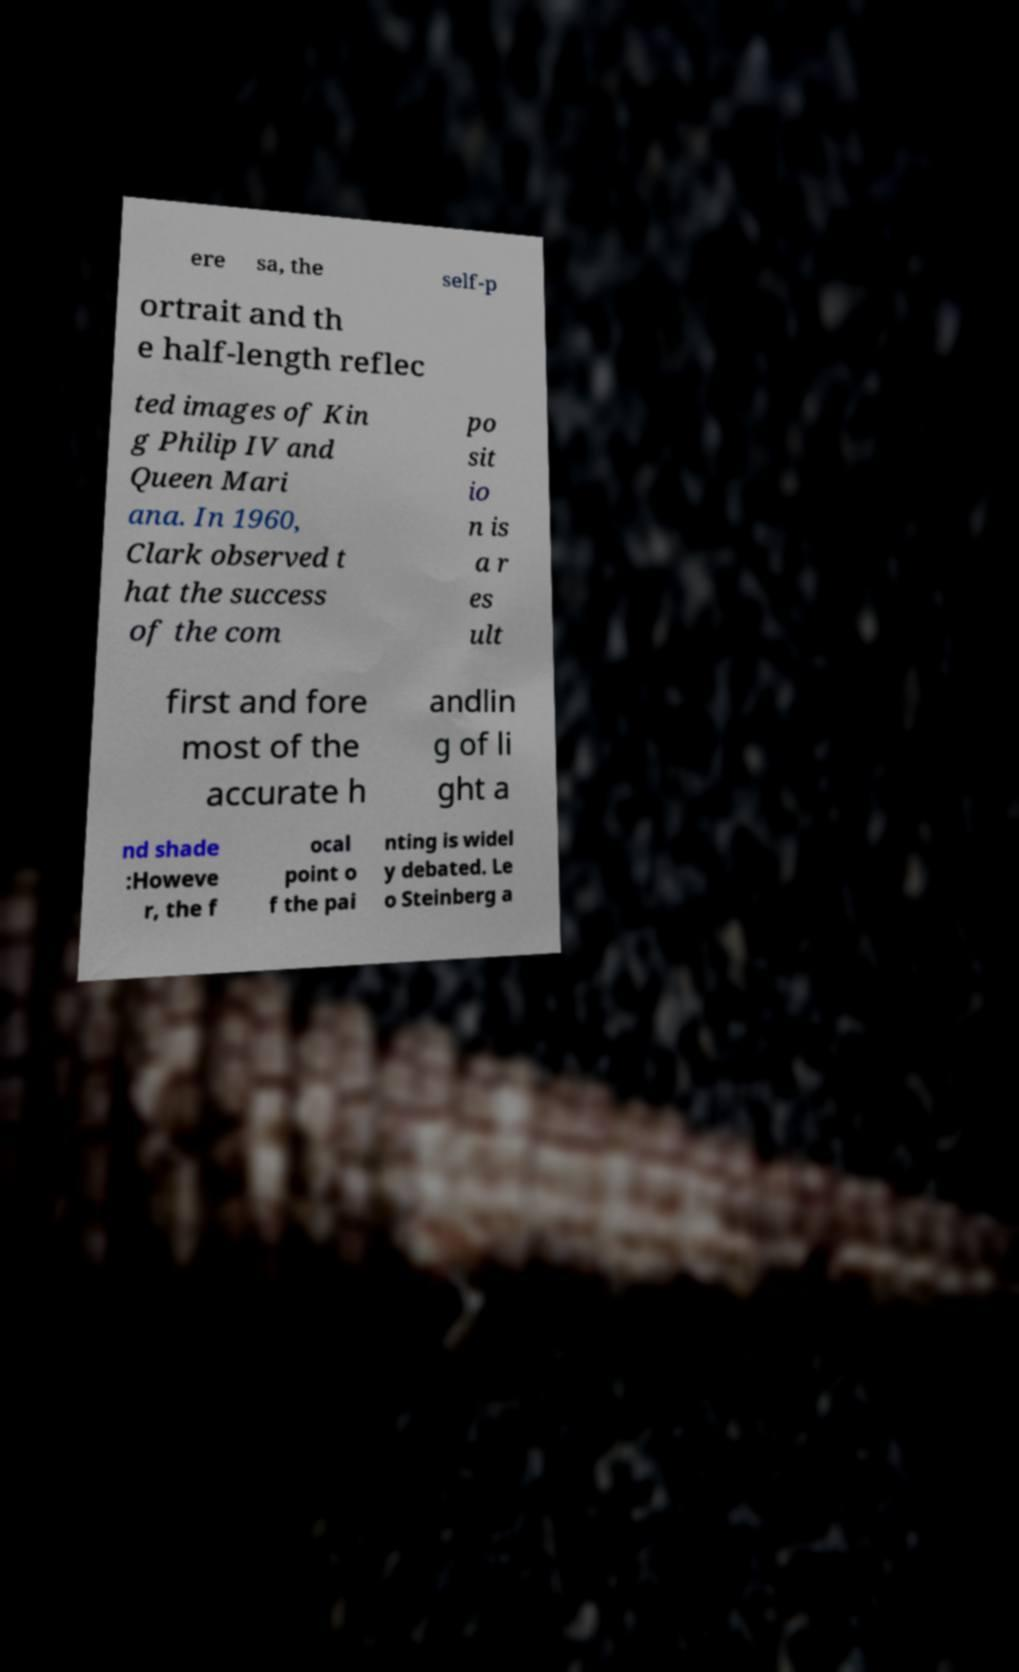What messages or text are displayed in this image? I need them in a readable, typed format. ere sa, the self-p ortrait and th e half-length reflec ted images of Kin g Philip IV and Queen Mari ana. In 1960, Clark observed t hat the success of the com po sit io n is a r es ult first and fore most of the accurate h andlin g of li ght a nd shade :Howeve r, the f ocal point o f the pai nting is widel y debated. Le o Steinberg a 